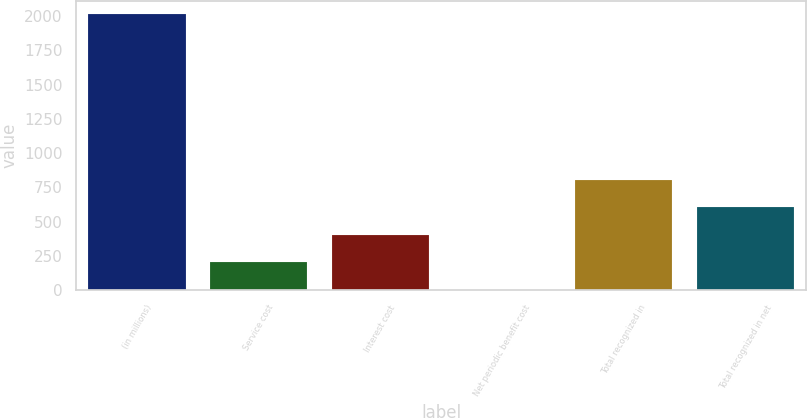Convert chart to OTSL. <chart><loc_0><loc_0><loc_500><loc_500><bar_chart><fcel>(in millions)<fcel>Service cost<fcel>Interest cost<fcel>Net periodic benefit cost<fcel>Total recognized in<fcel>Total recognized in net<nl><fcel>2013<fcel>204<fcel>405<fcel>3<fcel>807<fcel>606<nl></chart> 